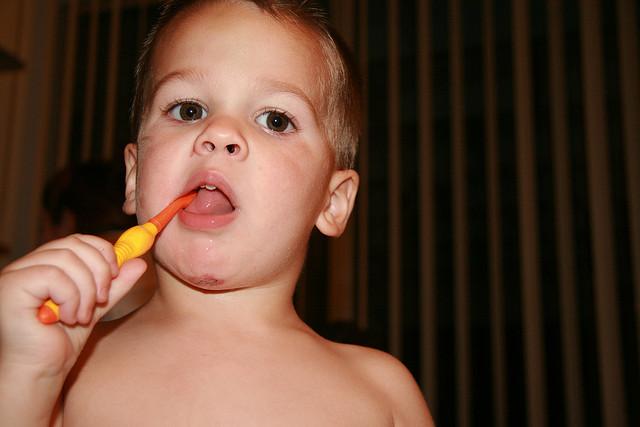What is the child eating?
Give a very brief answer. Toothbrush. What is the color of the persons toothbrush?
Short answer required. Yellow and orange. Are those blinds behind the boy?
Answer briefly. Yes. What fruit is the child holding?
Keep it brief. None. Can you see the boy's mouth?
Write a very short answer. Yes. What is this boy doing?
Keep it brief. Brushing teeth. Is the kid feasting on a banana?
Give a very brief answer. No. 